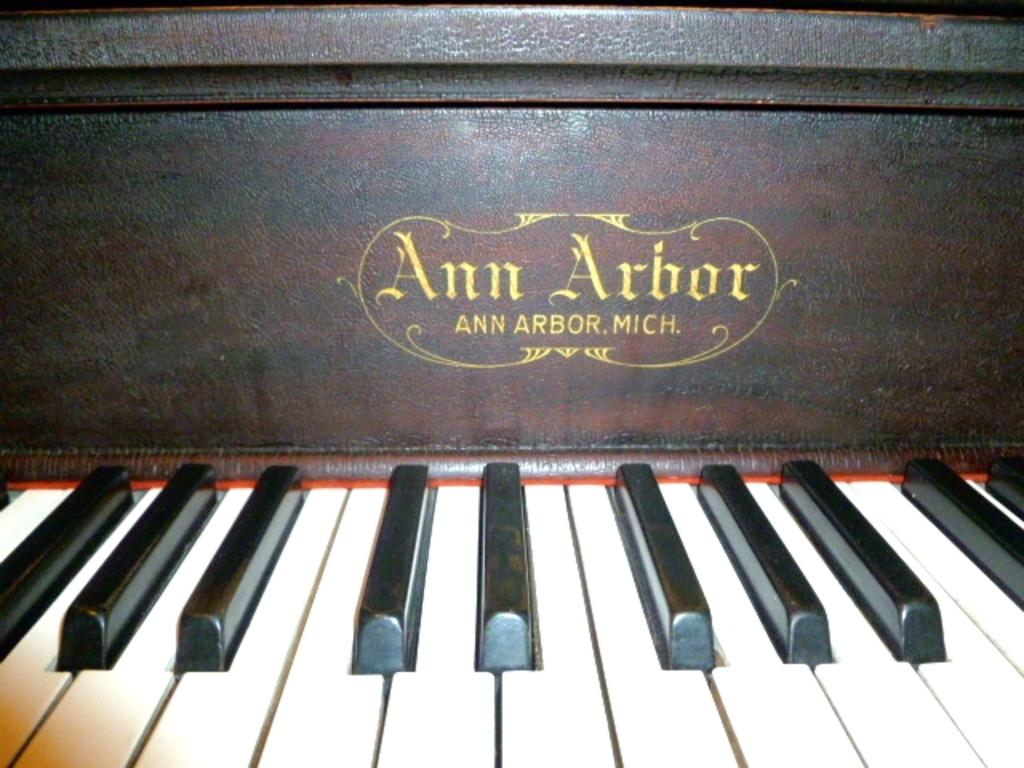What is the main subject of the picture? The main subject of the picture is a piano keyboard. Can you describe the piano keyboard in the picture? The piano keyboard is highlighted in the picture. What type of tail can be seen on the piano keyboard in the image? There is no tail present on the piano keyboard in the image. 